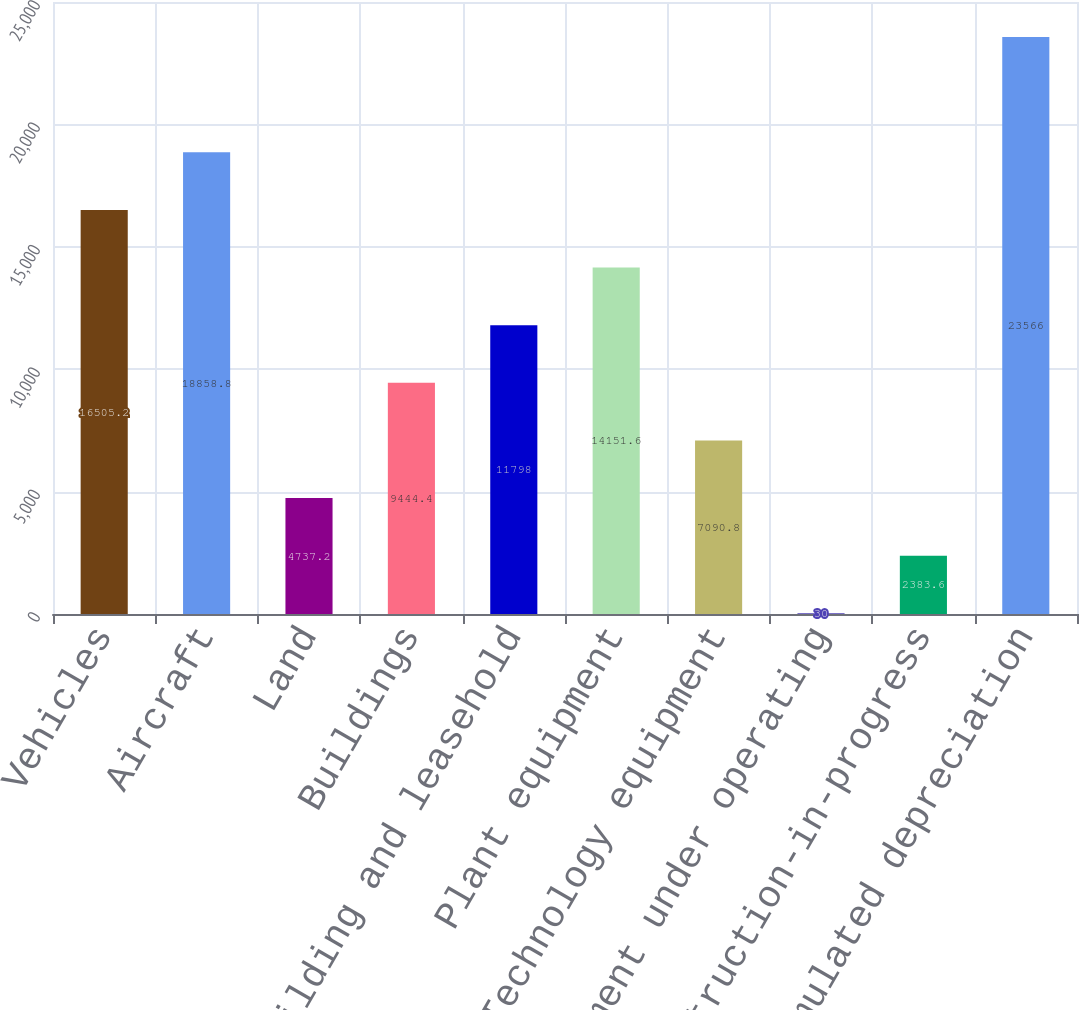<chart> <loc_0><loc_0><loc_500><loc_500><bar_chart><fcel>Vehicles<fcel>Aircraft<fcel>Land<fcel>Buildings<fcel>Building and leasehold<fcel>Plant equipment<fcel>Technology equipment<fcel>Equipment under operating<fcel>Construction-in-progress<fcel>Less Accumulated depreciation<nl><fcel>16505.2<fcel>18858.8<fcel>4737.2<fcel>9444.4<fcel>11798<fcel>14151.6<fcel>7090.8<fcel>30<fcel>2383.6<fcel>23566<nl></chart> 